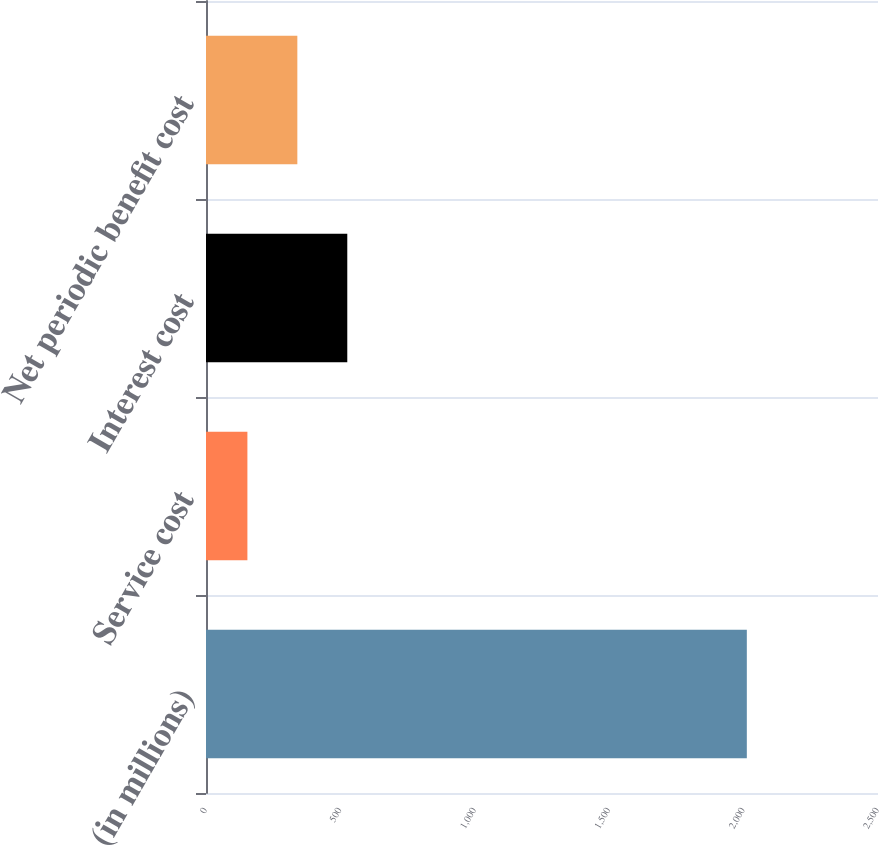Convert chart. <chart><loc_0><loc_0><loc_500><loc_500><bar_chart><fcel>(in millions)<fcel>Service cost<fcel>Interest cost<fcel>Net periodic benefit cost<nl><fcel>2012<fcel>154<fcel>525.6<fcel>339.8<nl></chart> 